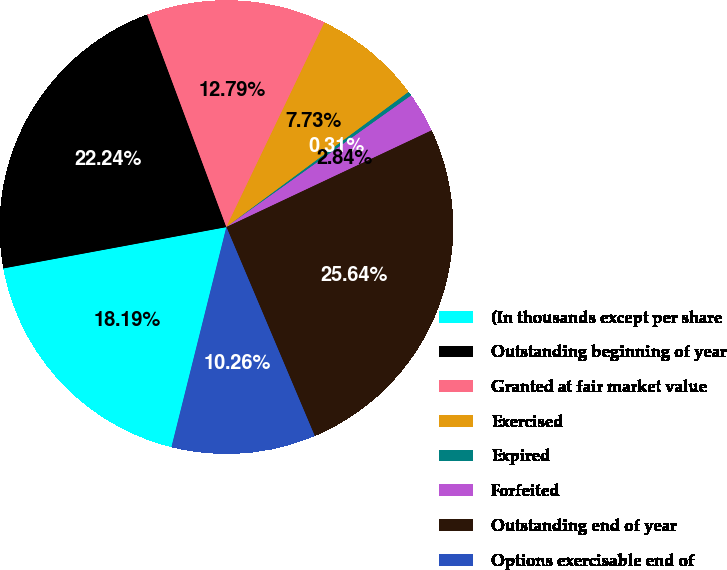Convert chart. <chart><loc_0><loc_0><loc_500><loc_500><pie_chart><fcel>(In thousands except per share<fcel>Outstanding beginning of year<fcel>Granted at fair market value<fcel>Exercised<fcel>Expired<fcel>Forfeited<fcel>Outstanding end of year<fcel>Options exercisable end of<nl><fcel>18.19%<fcel>22.24%<fcel>12.79%<fcel>7.73%<fcel>0.31%<fcel>2.84%<fcel>25.64%<fcel>10.26%<nl></chart> 